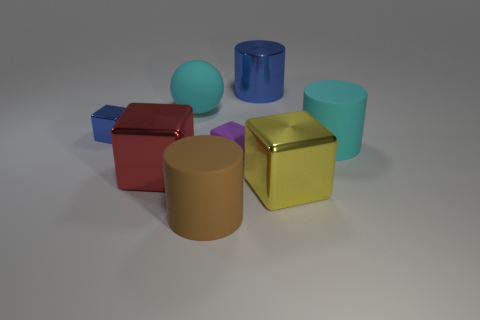Add 2 yellow cubes. How many objects exist? 10 Subtract 0 blue spheres. How many objects are left? 8 Subtract all balls. How many objects are left? 7 Subtract all big red cylinders. Subtract all cyan balls. How many objects are left? 7 Add 3 cyan rubber cylinders. How many cyan rubber cylinders are left? 4 Add 8 big red cubes. How many big red cubes exist? 9 